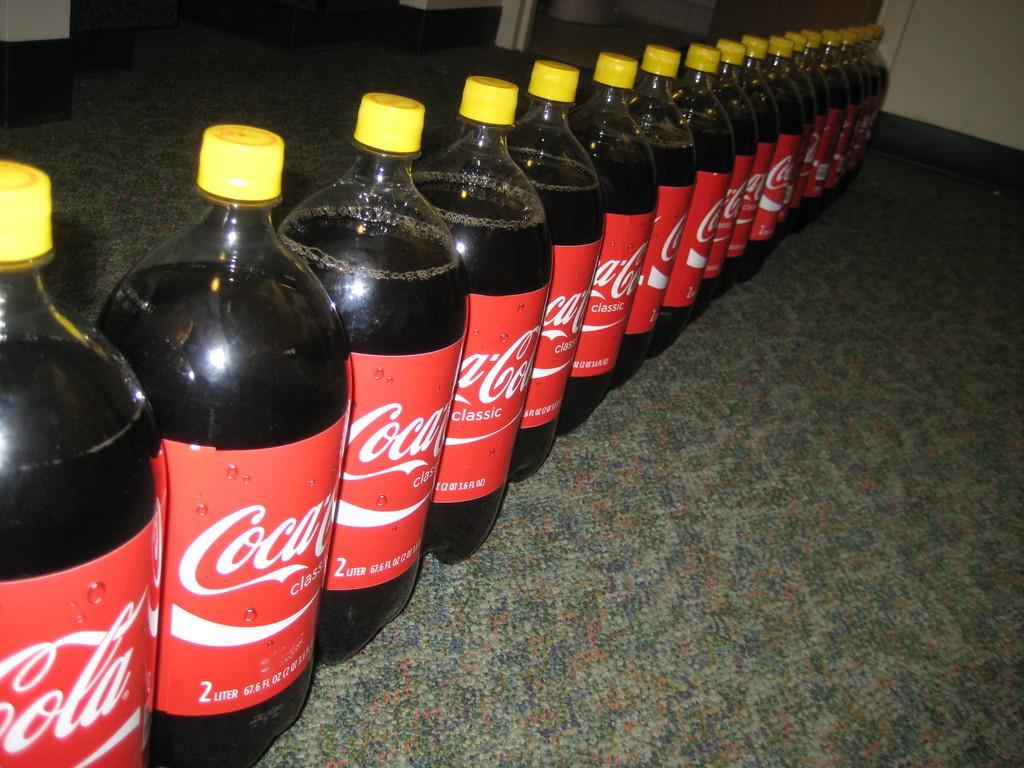In one or two sentences, can you explain what this image depicts? There are many bottles with coca cola label and yellow color cap is kept is kept on a surface. 